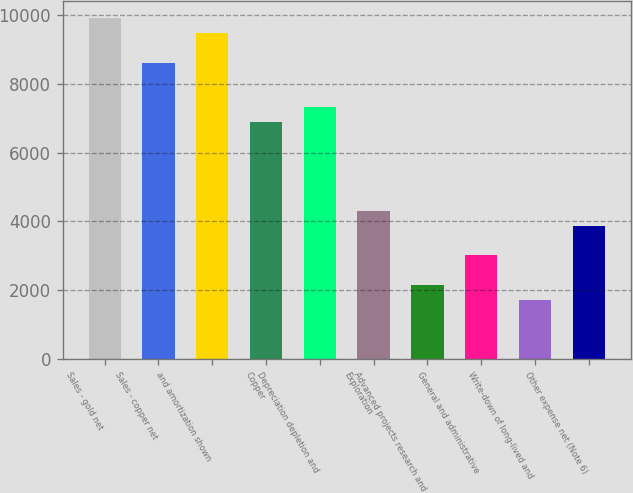Convert chart. <chart><loc_0><loc_0><loc_500><loc_500><bar_chart><fcel>Sales - gold net<fcel>Sales - copper net<fcel>and amortization shown<fcel>Copper<fcel>Depreciation depletion and<fcel>Exploration<fcel>Advanced projects research and<fcel>General and administrative<fcel>Write-down of long-lived and<fcel>Other expense net (Note 6)<nl><fcel>9900.98<fcel>8609.6<fcel>9470.52<fcel>6887.76<fcel>7318.22<fcel>4305<fcel>2152.7<fcel>3013.62<fcel>1722.24<fcel>3874.54<nl></chart> 